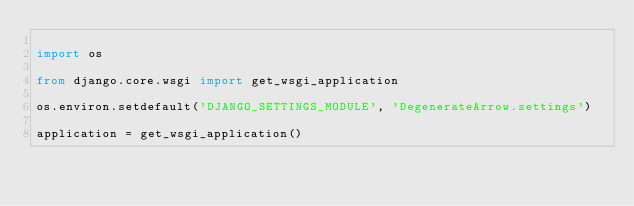<code> <loc_0><loc_0><loc_500><loc_500><_Python_>
import os

from django.core.wsgi import get_wsgi_application

os.environ.setdefault('DJANGO_SETTINGS_MODULE', 'DegenerateArrow.settings')

application = get_wsgi_application()
</code> 